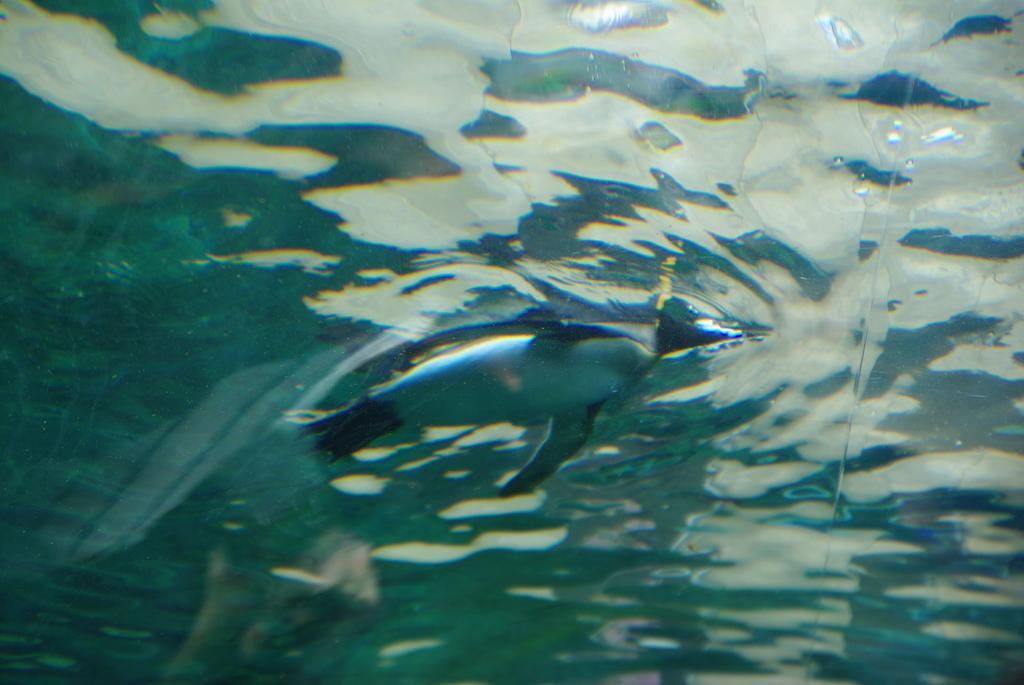Can you describe this image briefly? In the picture I can see a penguin swimming in the water. 